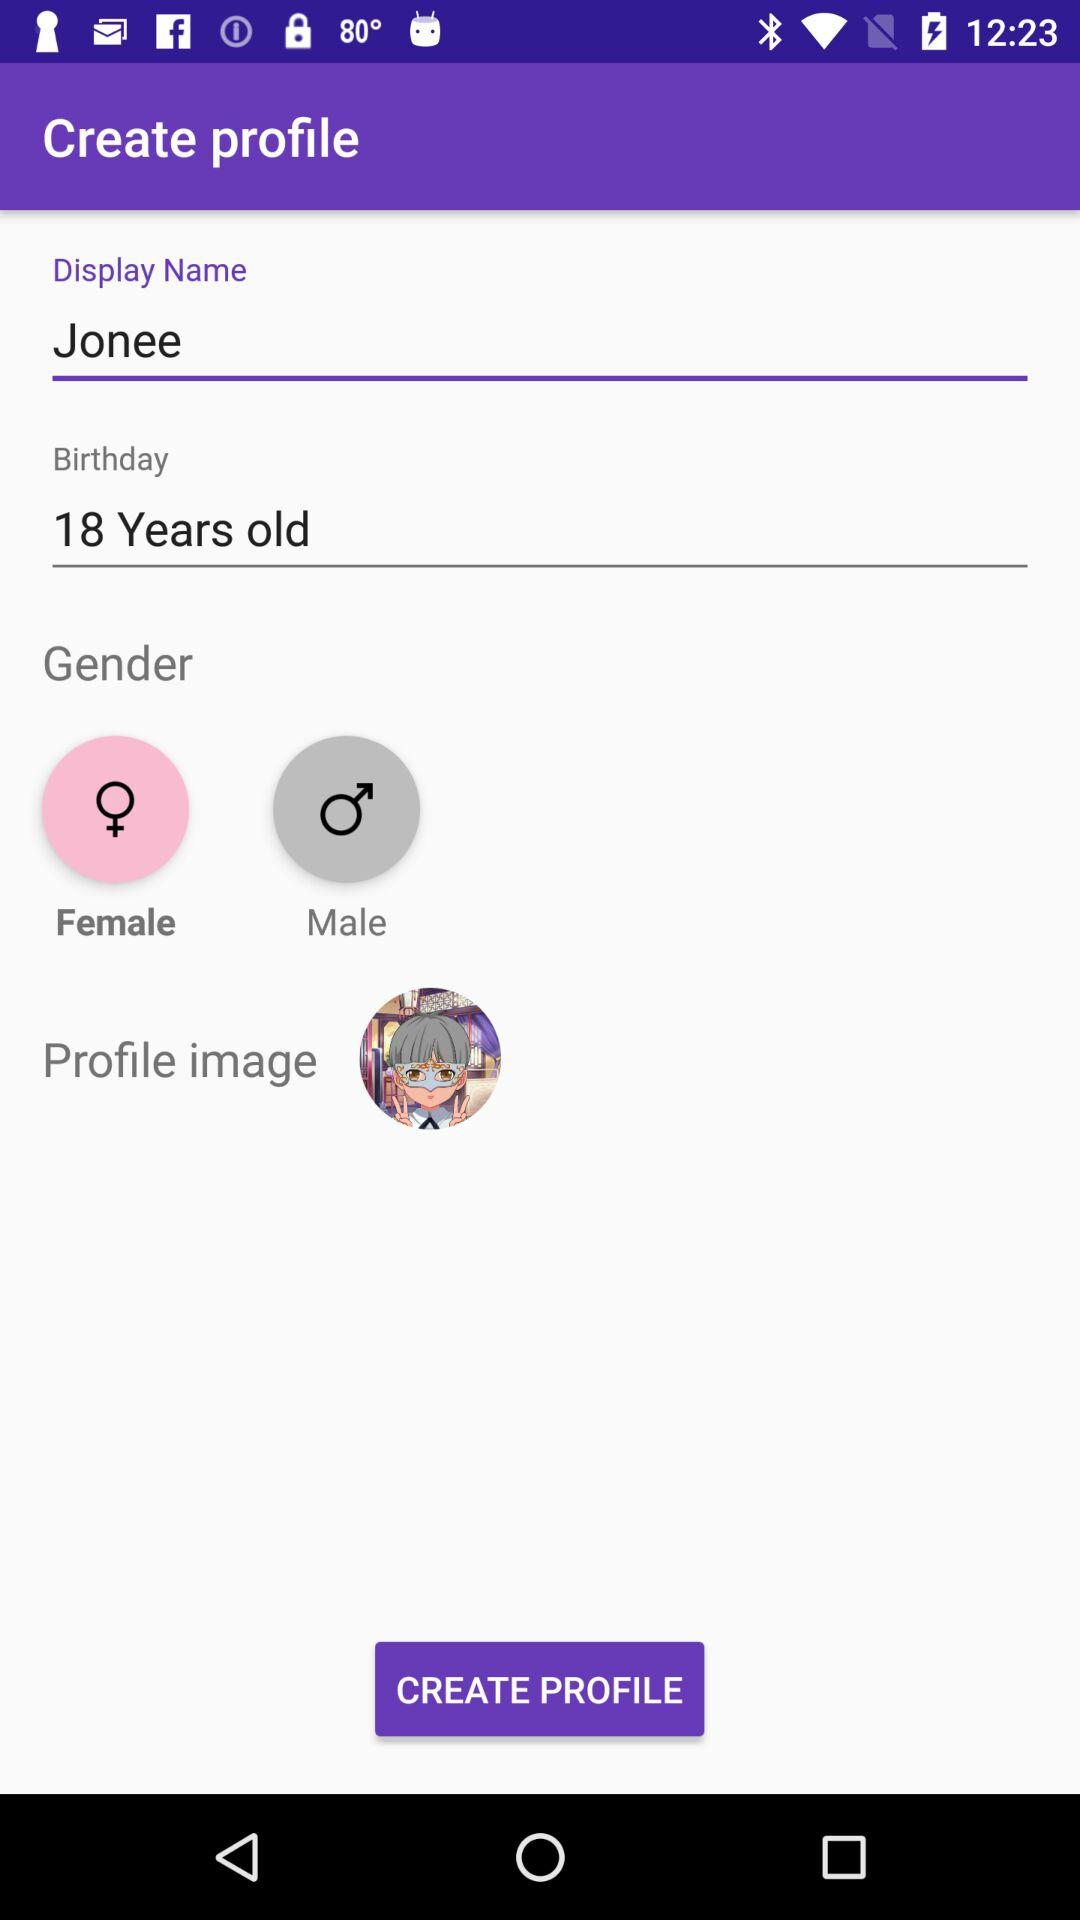Which gender is selected? The selected gender is female. 